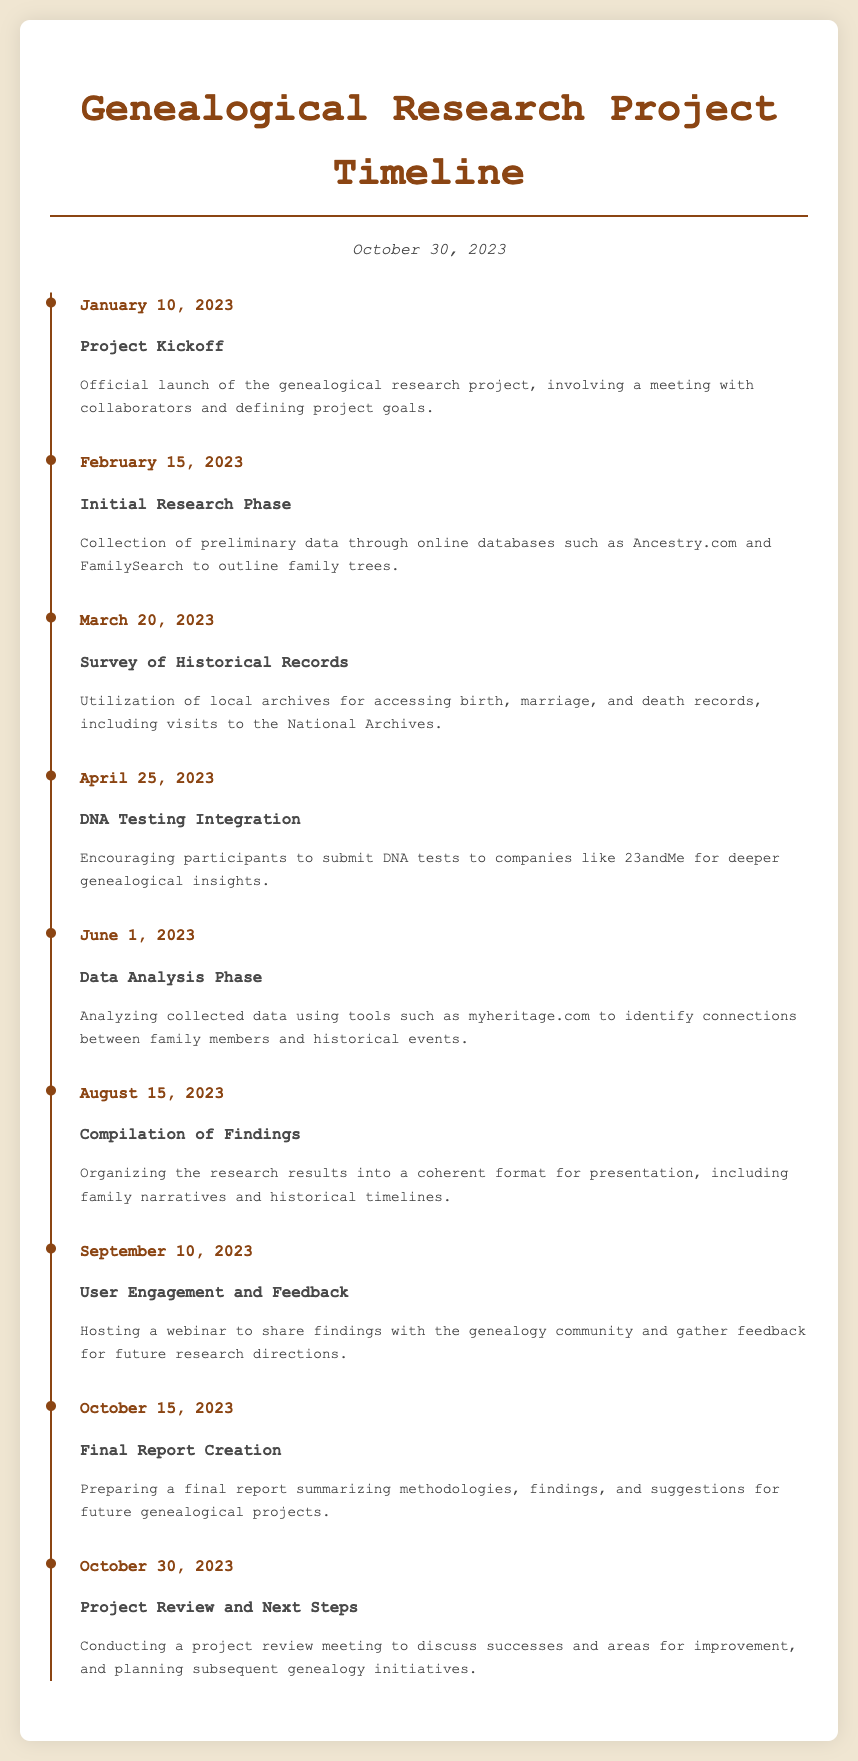what is the date of the project kickoff? The date of the project kickoff is specifically mentioned in the document.
Answer: January 10, 2023 what significant event occurred on June 1, 2023? This date marks the beginning of the Data Analysis Phase within the project timeline.
Answer: Data Analysis Phase how many milestones are listed in the document? The document outlines a total of eight milestones from the start to the final review.
Answer: 8 what was the main activity on October 30, 2023? The last event in the timeline focuses on project review and discussing next steps for future research.
Answer: Project Review and Next Steps which online database was used for the initial research phase? The document explicitly mentions specific online platforms used in this phase.
Answer: Ancestry.com and FamilySearch what is the purpose of the October 15, 2023 milestone? This milestone aims to create a final report summing up the entire research initiative.
Answer: Final Report Creation which company was mentioned for DNA testing? The document cites a particular company that participants were encouraged to use for DNA testing.
Answer: 23andMe when was user engagement and feedback initiated? The date specified for user engagement and feedback in the timeline is essential information provided.
Answer: September 10, 2023 